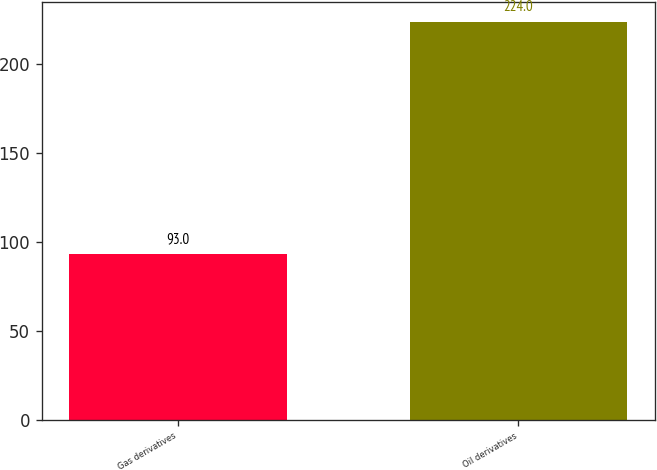Convert chart to OTSL. <chart><loc_0><loc_0><loc_500><loc_500><bar_chart><fcel>Gas derivatives<fcel>Oil derivatives<nl><fcel>93<fcel>224<nl></chart> 